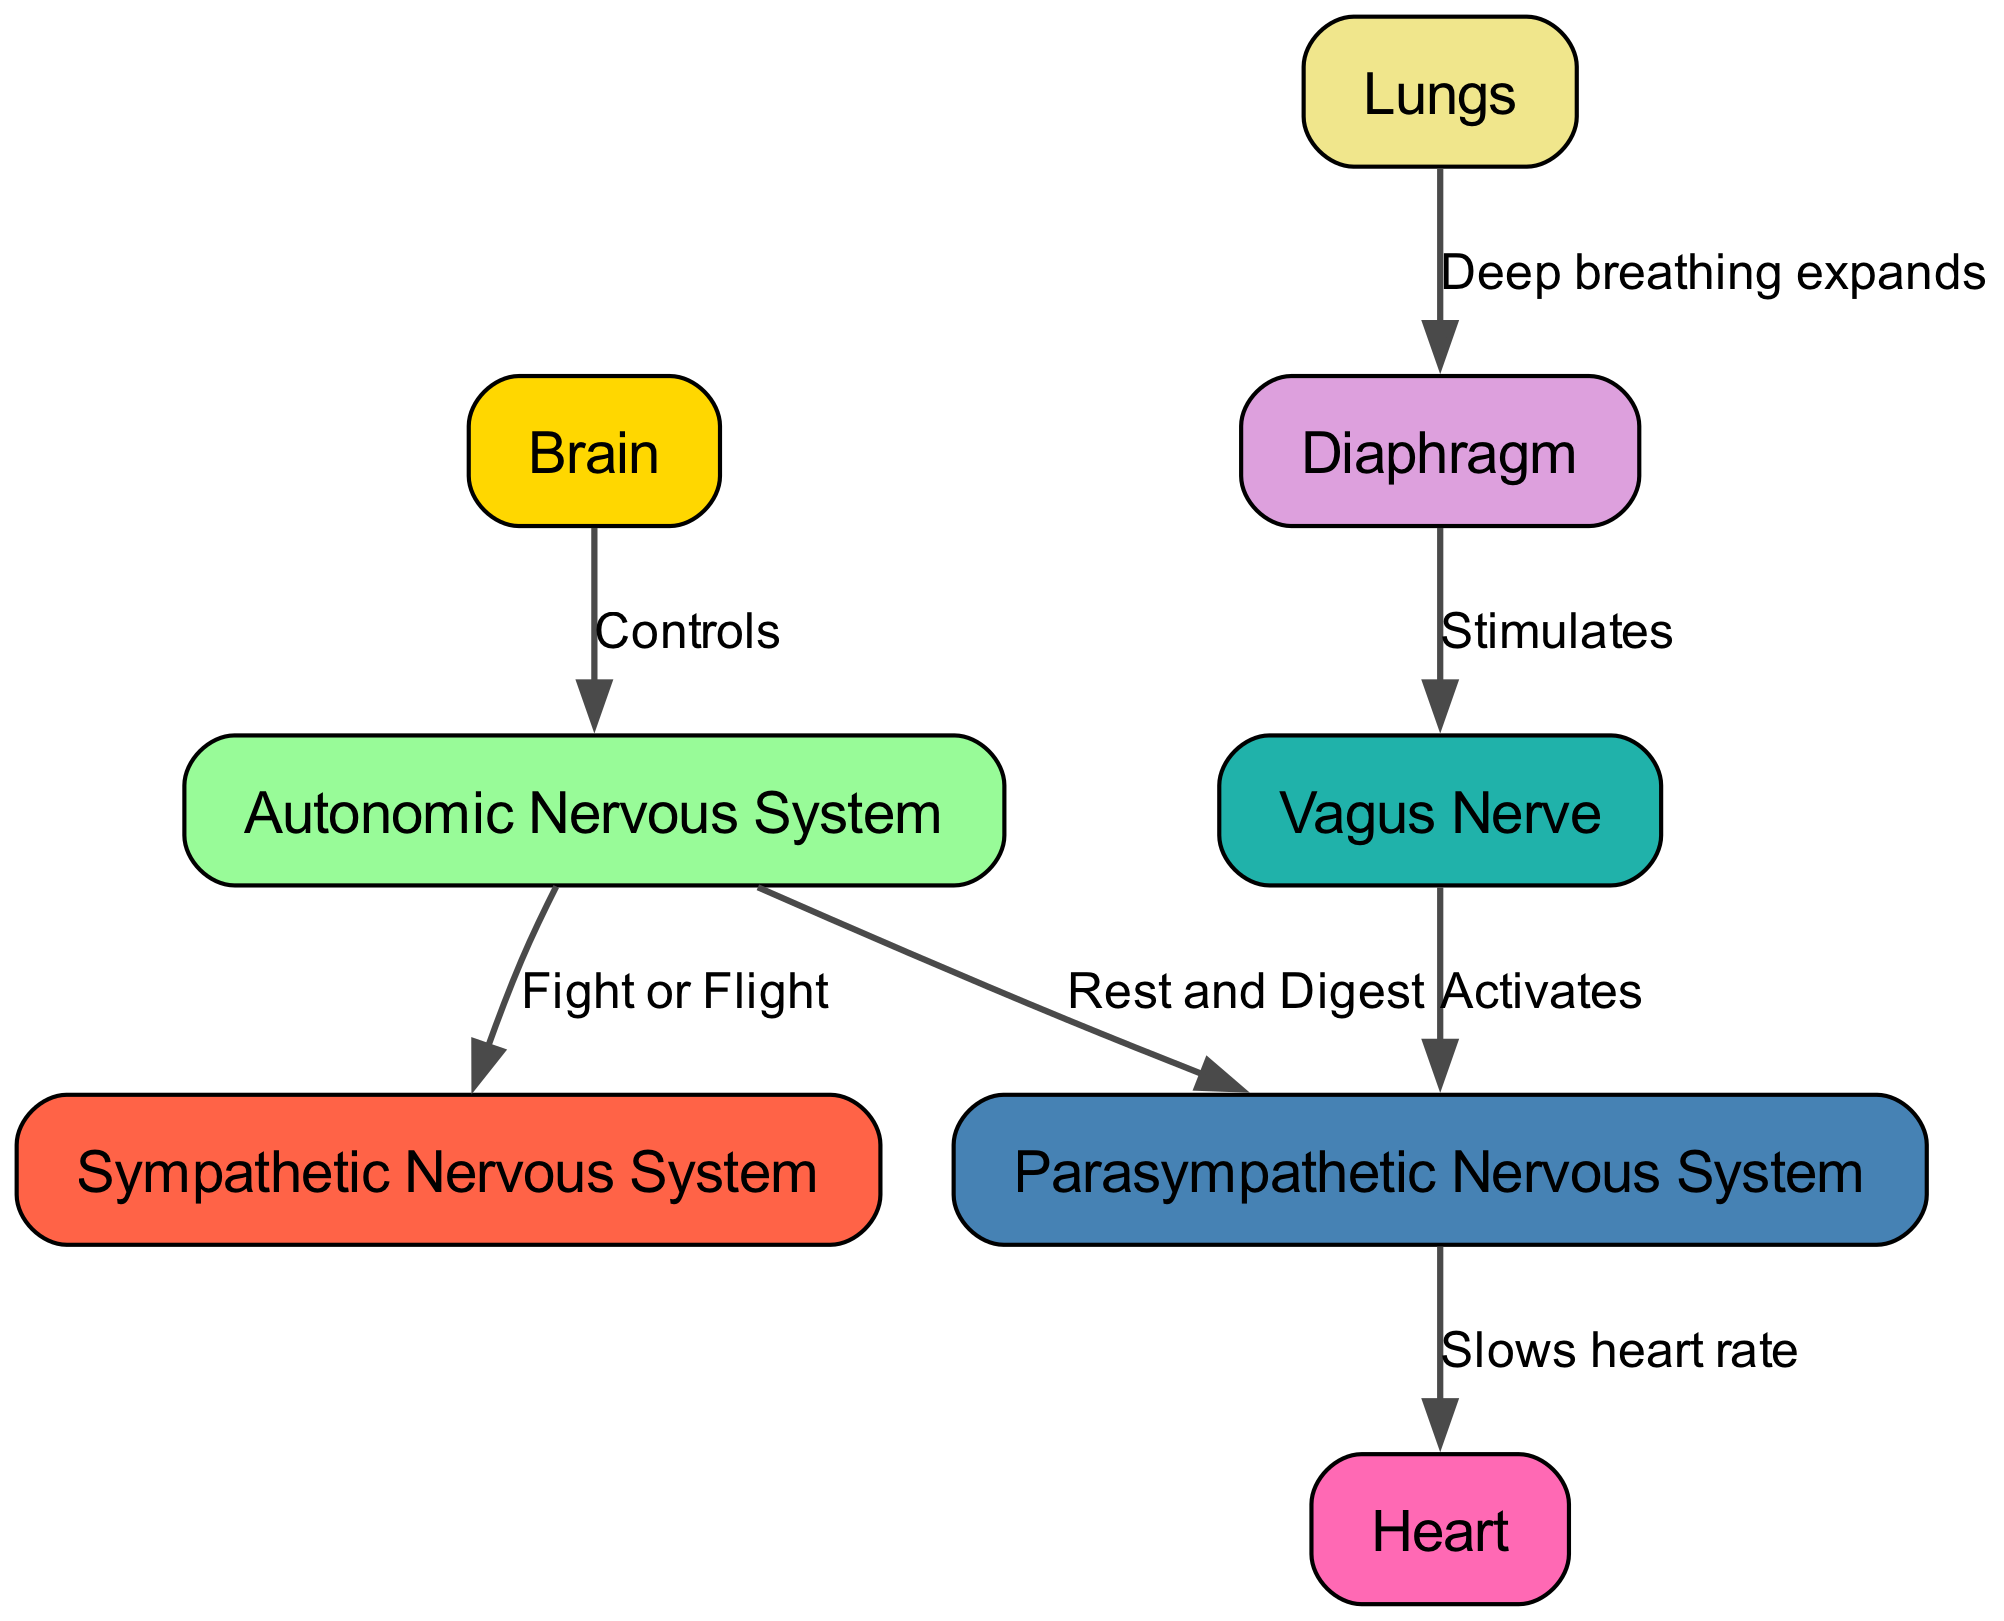What is the role of the brain in this diagram? The brain is the primary control center for the autonomic nervous system, as indicated by its direct connection to the autonomic nervous system node. This shows that all autonomic functions are regulated by the brain.
Answer: Controls How many nodes are present in the diagram? The diagram contains a total of 8 nodes, including the brain, autonomic nervous system, sympathetic nervous system, parasympathetic nervous system, lungs, diaphragm, heart, and vagus nerve.
Answer: 8 What type of response is activated by deep breathing? Deep breathing is linked to the activation of the parasympathetic nervous system, as seen through the connection from the diaphragm to the vagus nerve and then to the parasympathetic node.
Answer: Rest and Digest What effect does the parasympathetic nervous system have on the heart? The parasympathetic nervous system has the effect of slowing the heart rate, which is explicitly stated in the edge connecting the parasympathetic node to the heart node.
Answer: Slows heart rate What stimulates the vagus nerve according to the diagram? The vagus nerve is stimulated by the diaphragm as indicated by the edge connecting these two nodes. This demonstrates the pathway from breathing to nerve activation.
Answer: Deep breathing expands What is the relationship between the autonomic nervous system and the sympathetic nervous system? The relationship is that the autonomic nervous system controls the sympathetic nervous system, indicated by the edge labeled "Fight or Flight" from the autonomic nervous system to the sympathetic nervous system.
Answer: Fight or Flight Which node connects the diaphragm and vagus nerve? The diagram shows that the diaphragm directly stimulates the vagus nerve, as represented by the specific edge linking these two nodes.
Answer: Diaphragm What is the primary function of the lungs in this diagram? The lungs are primarily involved in deep breathing, which expands the diaphragm, thereby influencing the autonomic nervous system as shown through the flow of connections in the diagram.
Answer: Deep breathing expands 